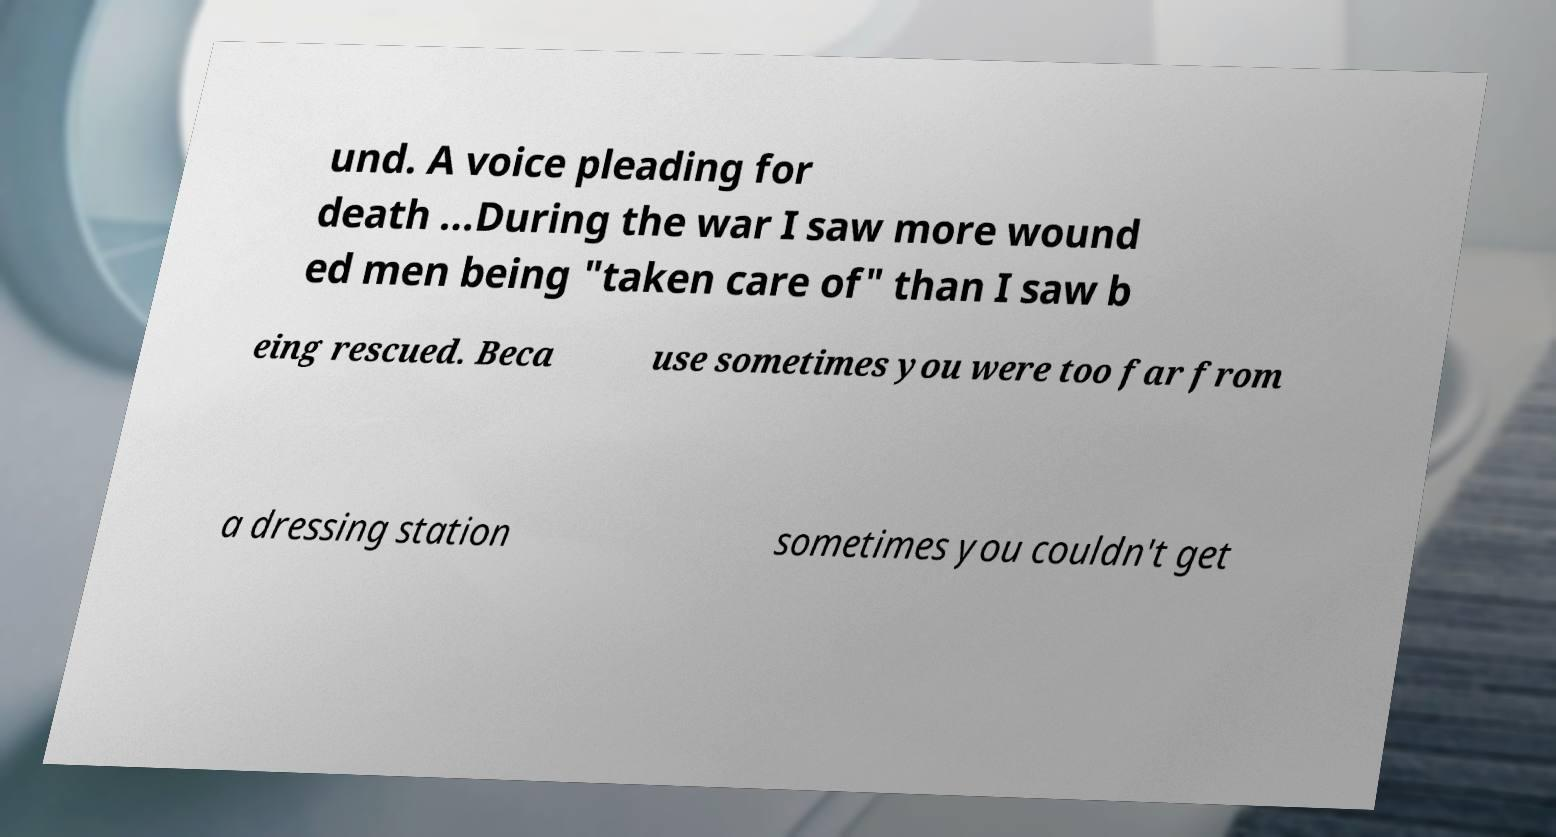Can you read and provide the text displayed in the image?This photo seems to have some interesting text. Can you extract and type it out for me? und. A voice pleading for death ...During the war I saw more wound ed men being "taken care of" than I saw b eing rescued. Beca use sometimes you were too far from a dressing station sometimes you couldn't get 